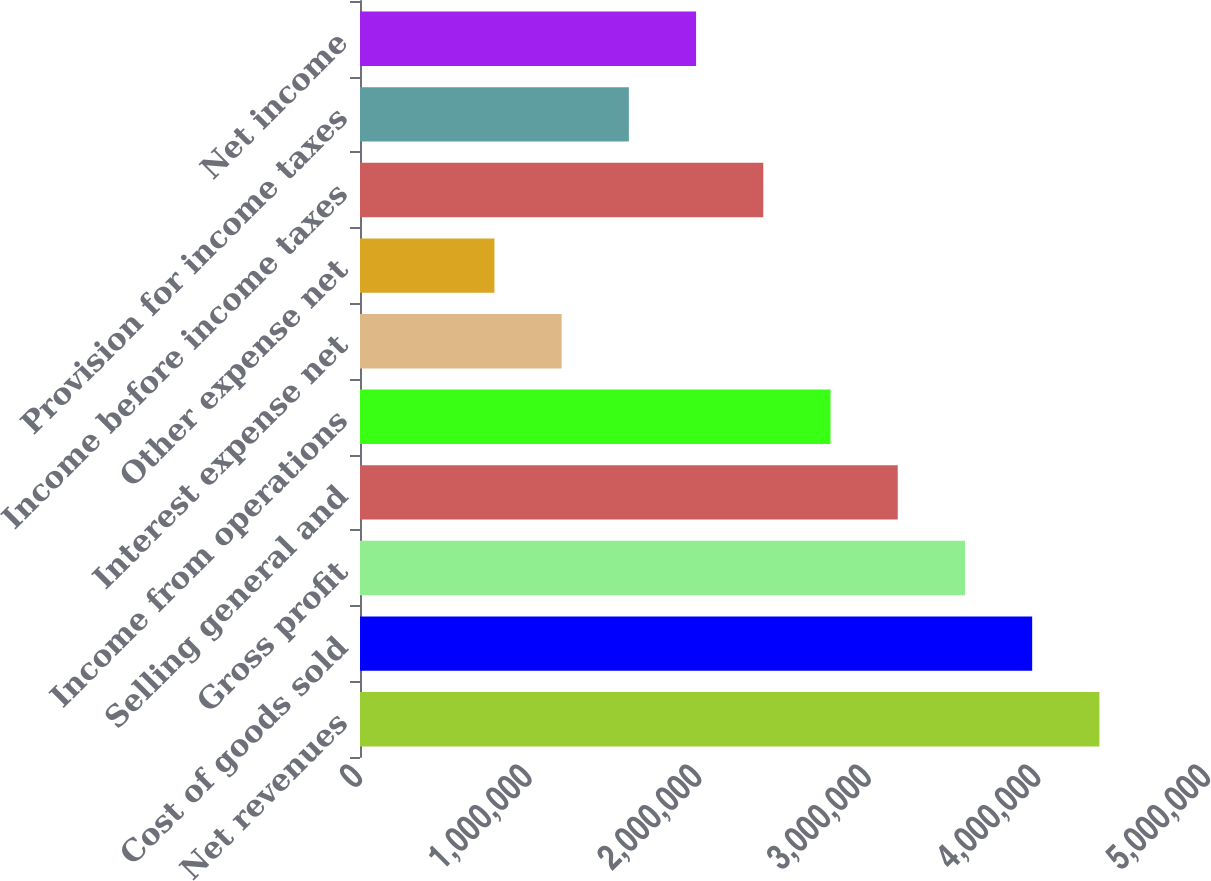Convert chart. <chart><loc_0><loc_0><loc_500><loc_500><bar_chart><fcel>Net revenues<fcel>Cost of goods sold<fcel>Gross profit<fcel>Selling general and<fcel>Income from operations<fcel>Interest expense net<fcel>Other expense net<fcel>Income before income taxes<fcel>Provision for income taxes<fcel>Net income<nl><fcel>4.35964e+06<fcel>3.96331e+06<fcel>3.56698e+06<fcel>3.17065e+06<fcel>2.77432e+06<fcel>1.18899e+06<fcel>792663<fcel>2.37799e+06<fcel>1.58533e+06<fcel>1.98166e+06<nl></chart> 